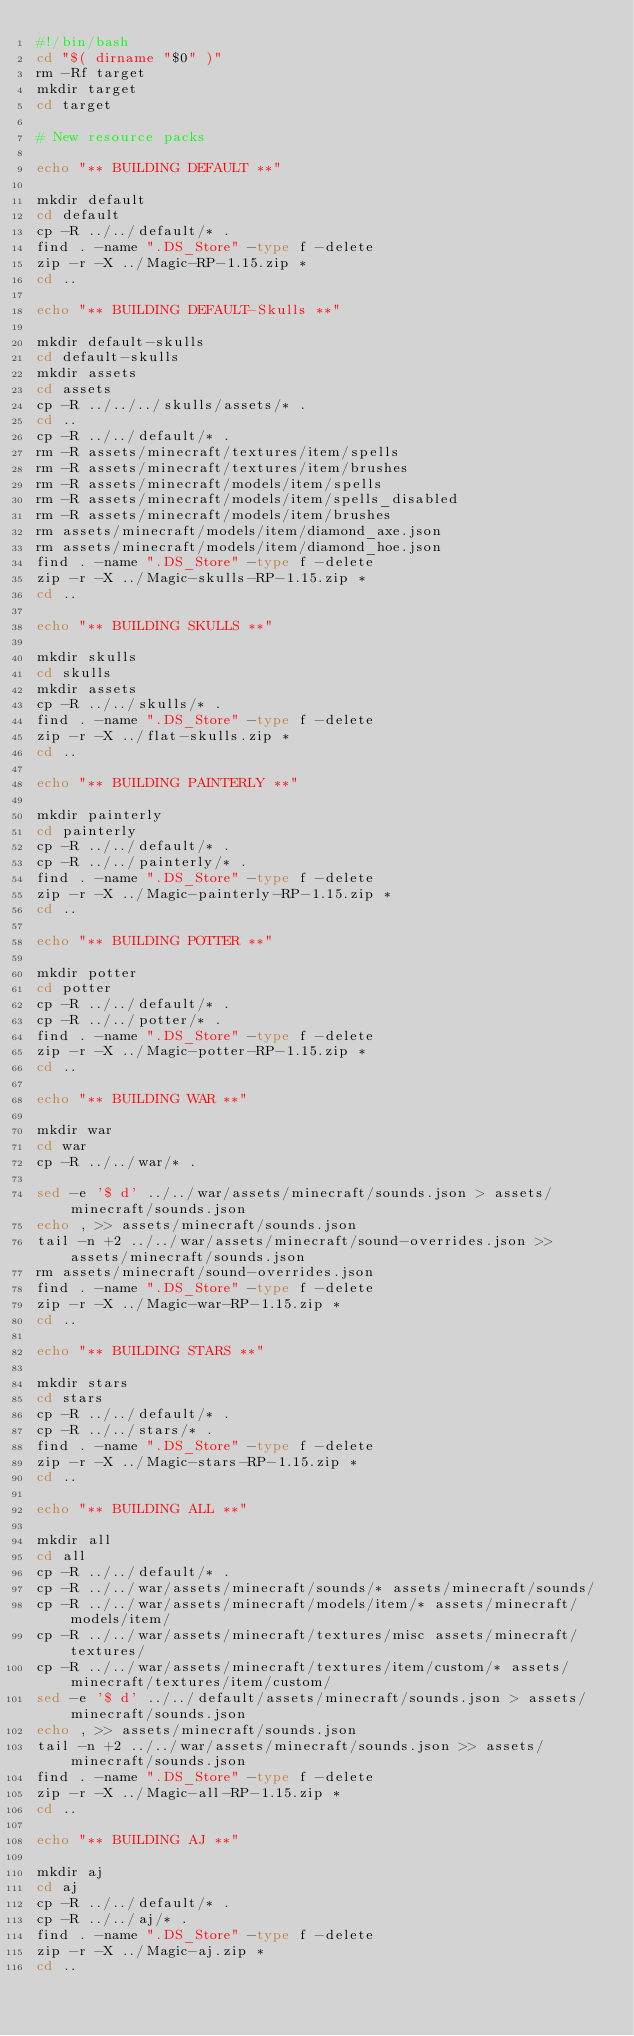<code> <loc_0><loc_0><loc_500><loc_500><_Bash_>#!/bin/bash
cd "$( dirname "$0" )"
rm -Rf target
mkdir target
cd target

# New resource packs

echo "** BUILDING DEFAULT **"

mkdir default
cd default
cp -R ../../default/* .
find . -name ".DS_Store" -type f -delete
zip -r -X ../Magic-RP-1.15.zip *
cd ..

echo "** BUILDING DEFAULT-Skulls **"

mkdir default-skulls
cd default-skulls
mkdir assets
cd assets
cp -R ../../../skulls/assets/* .
cd ..
cp -R ../../default/* .
rm -R assets/minecraft/textures/item/spells
rm -R assets/minecraft/textures/item/brushes
rm -R assets/minecraft/models/item/spells
rm -R assets/minecraft/models/item/spells_disabled
rm -R assets/minecraft/models/item/brushes
rm assets/minecraft/models/item/diamond_axe.json
rm assets/minecraft/models/item/diamond_hoe.json
find . -name ".DS_Store" -type f -delete
zip -r -X ../Magic-skulls-RP-1.15.zip *
cd ..

echo "** BUILDING SKULLS **"

mkdir skulls
cd skulls
mkdir assets
cp -R ../../skulls/* .
find . -name ".DS_Store" -type f -delete
zip -r -X ../flat-skulls.zip *
cd ..

echo "** BUILDING PAINTERLY **"

mkdir painterly
cd painterly
cp -R ../../default/* .
cp -R ../../painterly/* .
find . -name ".DS_Store" -type f -delete
zip -r -X ../Magic-painterly-RP-1.15.zip *
cd ..

echo "** BUILDING POTTER **"

mkdir potter 
cd potter
cp -R ../../default/* .
cp -R ../../potter/* .
find . -name ".DS_Store" -type f -delete
zip -r -X ../Magic-potter-RP-1.15.zip *
cd ..

echo "** BUILDING WAR **"

mkdir war
cd war
cp -R ../../war/* .

sed -e '$ d' ../../war/assets/minecraft/sounds.json > assets/minecraft/sounds.json
echo , >> assets/minecraft/sounds.json
tail -n +2 ../../war/assets/minecraft/sound-overrides.json >> assets/minecraft/sounds.json
rm assets/minecraft/sound-overrides.json
find . -name ".DS_Store" -type f -delete
zip -r -X ../Magic-war-RP-1.15.zip *
cd ..

echo "** BUILDING STARS **"

mkdir stars
cd stars
cp -R ../../default/* .
cp -R ../../stars/* .
find . -name ".DS_Store" -type f -delete
zip -r -X ../Magic-stars-RP-1.15.zip *
cd ..

echo "** BUILDING ALL **"

mkdir all
cd all
cp -R ../../default/* .
cp -R ../../war/assets/minecraft/sounds/* assets/minecraft/sounds/
cp -R ../../war/assets/minecraft/models/item/* assets/minecraft/models/item/
cp -R ../../war/assets/minecraft/textures/misc assets/minecraft/textures/
cp -R ../../war/assets/minecraft/textures/item/custom/* assets/minecraft/textures/item/custom/
sed -e '$ d' ../../default/assets/minecraft/sounds.json > assets/minecraft/sounds.json
echo , >> assets/minecraft/sounds.json
tail -n +2 ../../war/assets/minecraft/sounds.json >> assets/minecraft/sounds.json
find . -name ".DS_Store" -type f -delete
zip -r -X ../Magic-all-RP-1.15.zip *
cd ..

echo "** BUILDING AJ **"

mkdir aj
cd aj
cp -R ../../default/* .
cp -R ../../aj/* .
find . -name ".DS_Store" -type f -delete
zip -r -X ../Magic-aj.zip *
cd ..
</code> 